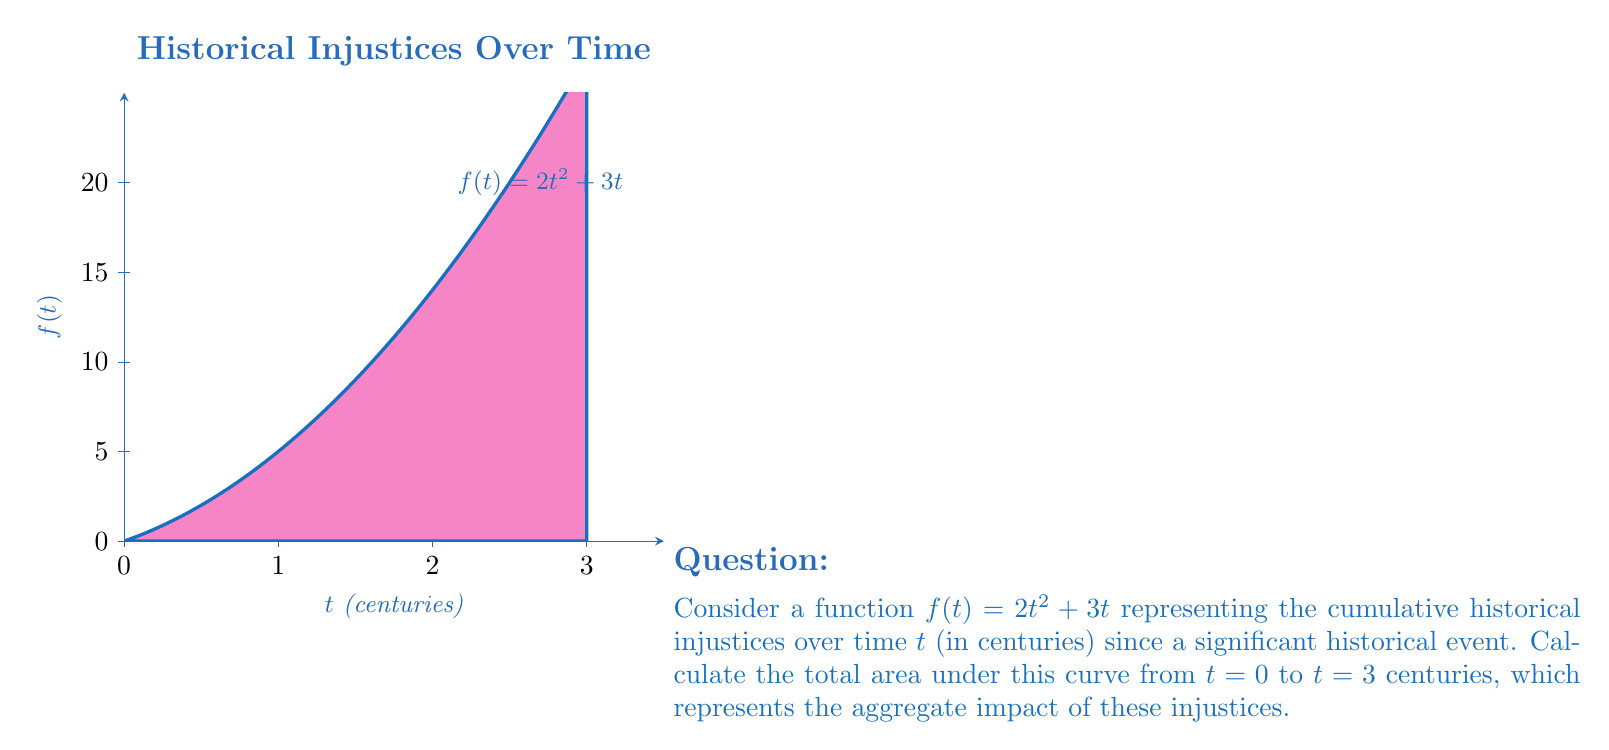Can you answer this question? To find the area under the curve, we need to integrate the function $f(t) = 2t^2 + 3t$ from $t=0$ to $t=3$. Here's the step-by-step process:

1) Set up the definite integral:
   $$\int_0^3 (2t^2 + 3t) dt$$

2) Integrate the function:
   $$\int (2t^2 + 3t) dt = \frac{2t^3}{3} + \frac{3t^2}{2} + C$$

3) Apply the limits of integration:
   $$\left[\frac{2t^3}{3} + \frac{3t^2}{2}\right]_0^3$$

4) Evaluate at the upper limit $(t=3)$:
   $$\frac{2(3^3)}{3} + \frac{3(3^2)}{2} = 18 + \frac{27}{2} = 18 + 13.5 = 31.5$$

5) Evaluate at the lower limit $(t=0)$:
   $$\frac{2(0^3)}{3} + \frac{3(0^2)}{2} = 0 + 0 = 0$$

6) Subtract the lower limit result from the upper limit result:
   $$31.5 - 0 = 31.5$$

Thus, the total area under the curve, representing the aggregate impact of historical injustices over 3 centuries, is 31.5 units².
Answer: 31.5 units² 